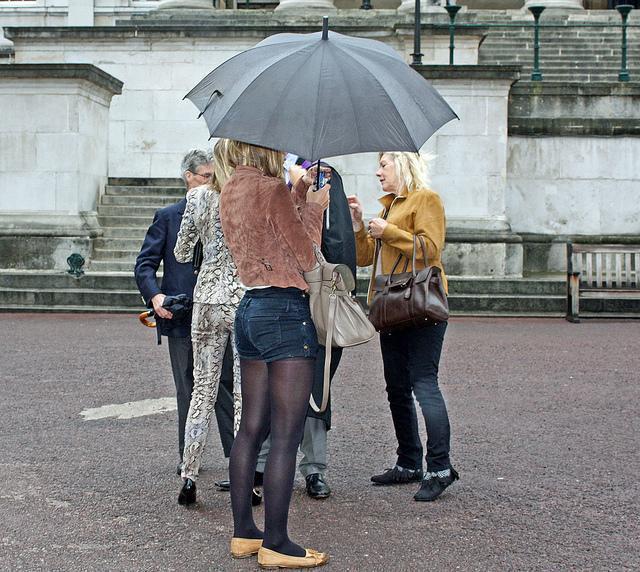From what materials is the wall made?
Select the correct answer and articulate reasoning with the following format: 'Answer: answer
Rationale: rationale.'
Options: Blocks, wood, tile, bricks. Answer: blocks.
Rationale: The materials are blocks. 